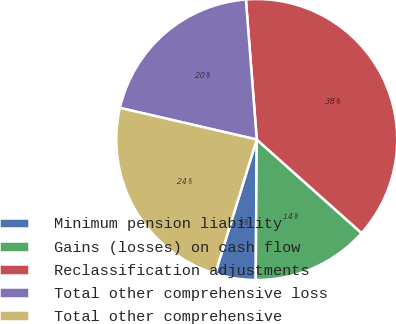<chart> <loc_0><loc_0><loc_500><loc_500><pie_chart><fcel>Minimum pension liability<fcel>Gains (losses) on cash flow<fcel>Reclassification adjustments<fcel>Total other comprehensive loss<fcel>Total other comprehensive<nl><fcel>4.67%<fcel>13.52%<fcel>37.83%<fcel>20.15%<fcel>23.83%<nl></chart> 